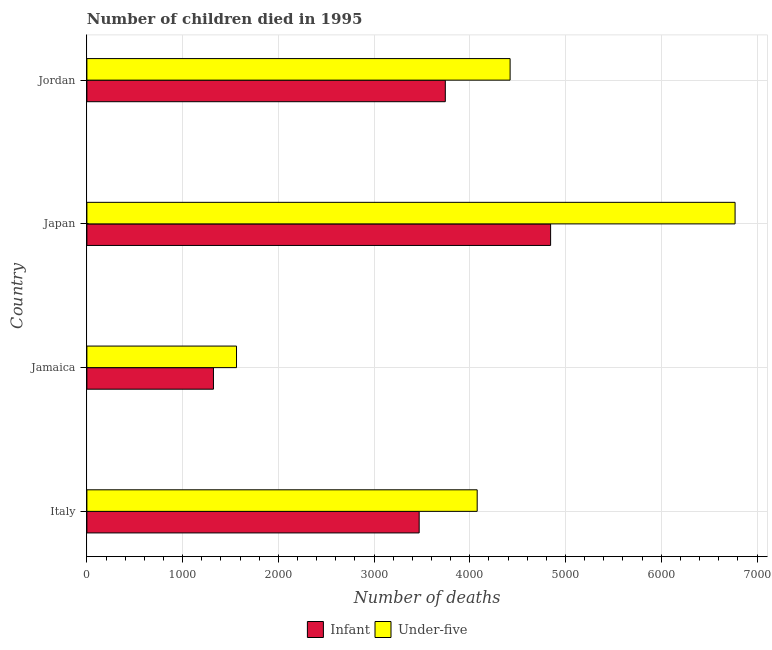How many different coloured bars are there?
Your answer should be very brief. 2. How many groups of bars are there?
Your answer should be compact. 4. Are the number of bars per tick equal to the number of legend labels?
Make the answer very short. Yes. What is the label of the 4th group of bars from the top?
Give a very brief answer. Italy. In how many cases, is the number of bars for a given country not equal to the number of legend labels?
Keep it short and to the point. 0. What is the number of infant deaths in Jordan?
Your answer should be compact. 3744. Across all countries, what is the maximum number of infant deaths?
Offer a very short reply. 4844. Across all countries, what is the minimum number of under-five deaths?
Provide a succinct answer. 1563. In which country was the number of infant deaths maximum?
Make the answer very short. Japan. In which country was the number of under-five deaths minimum?
Provide a succinct answer. Jamaica. What is the total number of under-five deaths in the graph?
Keep it short and to the point. 1.68e+04. What is the difference between the number of infant deaths in Japan and that in Jordan?
Offer a very short reply. 1100. What is the difference between the number of infant deaths in Jordan and the number of under-five deaths in Italy?
Your answer should be compact. -333. What is the average number of infant deaths per country?
Ensure brevity in your answer.  3345.25. What is the difference between the number of infant deaths and number of under-five deaths in Jamaica?
Make the answer very short. -241. What is the ratio of the number of under-five deaths in Jamaica to that in Jordan?
Keep it short and to the point. 0.35. Is the difference between the number of under-five deaths in Jamaica and Jordan greater than the difference between the number of infant deaths in Jamaica and Jordan?
Provide a short and direct response. No. What is the difference between the highest and the second highest number of infant deaths?
Your answer should be very brief. 1100. What is the difference between the highest and the lowest number of infant deaths?
Provide a short and direct response. 3522. What does the 2nd bar from the top in Jamaica represents?
Your answer should be compact. Infant. What does the 1st bar from the bottom in Italy represents?
Keep it short and to the point. Infant. What is the difference between two consecutive major ticks on the X-axis?
Provide a succinct answer. 1000. Are the values on the major ticks of X-axis written in scientific E-notation?
Your response must be concise. No. Does the graph contain grids?
Your answer should be very brief. Yes. Where does the legend appear in the graph?
Give a very brief answer. Bottom center. What is the title of the graph?
Provide a short and direct response. Number of children died in 1995. What is the label or title of the X-axis?
Offer a terse response. Number of deaths. What is the label or title of the Y-axis?
Your response must be concise. Country. What is the Number of deaths in Infant in Italy?
Your answer should be very brief. 3471. What is the Number of deaths of Under-five in Italy?
Your answer should be compact. 4077. What is the Number of deaths of Infant in Jamaica?
Your answer should be very brief. 1322. What is the Number of deaths in Under-five in Jamaica?
Your response must be concise. 1563. What is the Number of deaths in Infant in Japan?
Give a very brief answer. 4844. What is the Number of deaths in Under-five in Japan?
Provide a short and direct response. 6771. What is the Number of deaths of Infant in Jordan?
Your response must be concise. 3744. What is the Number of deaths in Under-five in Jordan?
Your answer should be compact. 4421. Across all countries, what is the maximum Number of deaths in Infant?
Keep it short and to the point. 4844. Across all countries, what is the maximum Number of deaths of Under-five?
Offer a very short reply. 6771. Across all countries, what is the minimum Number of deaths of Infant?
Offer a very short reply. 1322. Across all countries, what is the minimum Number of deaths of Under-five?
Keep it short and to the point. 1563. What is the total Number of deaths in Infant in the graph?
Your answer should be compact. 1.34e+04. What is the total Number of deaths in Under-five in the graph?
Keep it short and to the point. 1.68e+04. What is the difference between the Number of deaths in Infant in Italy and that in Jamaica?
Keep it short and to the point. 2149. What is the difference between the Number of deaths of Under-five in Italy and that in Jamaica?
Offer a very short reply. 2514. What is the difference between the Number of deaths of Infant in Italy and that in Japan?
Your response must be concise. -1373. What is the difference between the Number of deaths of Under-five in Italy and that in Japan?
Keep it short and to the point. -2694. What is the difference between the Number of deaths of Infant in Italy and that in Jordan?
Offer a terse response. -273. What is the difference between the Number of deaths of Under-five in Italy and that in Jordan?
Keep it short and to the point. -344. What is the difference between the Number of deaths of Infant in Jamaica and that in Japan?
Keep it short and to the point. -3522. What is the difference between the Number of deaths in Under-five in Jamaica and that in Japan?
Your answer should be compact. -5208. What is the difference between the Number of deaths of Infant in Jamaica and that in Jordan?
Make the answer very short. -2422. What is the difference between the Number of deaths in Under-five in Jamaica and that in Jordan?
Your answer should be very brief. -2858. What is the difference between the Number of deaths of Infant in Japan and that in Jordan?
Provide a succinct answer. 1100. What is the difference between the Number of deaths in Under-five in Japan and that in Jordan?
Provide a succinct answer. 2350. What is the difference between the Number of deaths of Infant in Italy and the Number of deaths of Under-five in Jamaica?
Your answer should be very brief. 1908. What is the difference between the Number of deaths in Infant in Italy and the Number of deaths in Under-five in Japan?
Offer a very short reply. -3300. What is the difference between the Number of deaths of Infant in Italy and the Number of deaths of Under-five in Jordan?
Give a very brief answer. -950. What is the difference between the Number of deaths in Infant in Jamaica and the Number of deaths in Under-five in Japan?
Provide a short and direct response. -5449. What is the difference between the Number of deaths in Infant in Jamaica and the Number of deaths in Under-five in Jordan?
Offer a terse response. -3099. What is the difference between the Number of deaths of Infant in Japan and the Number of deaths of Under-five in Jordan?
Your response must be concise. 423. What is the average Number of deaths in Infant per country?
Your answer should be compact. 3345.25. What is the average Number of deaths in Under-five per country?
Ensure brevity in your answer.  4208. What is the difference between the Number of deaths of Infant and Number of deaths of Under-five in Italy?
Make the answer very short. -606. What is the difference between the Number of deaths in Infant and Number of deaths in Under-five in Jamaica?
Provide a succinct answer. -241. What is the difference between the Number of deaths of Infant and Number of deaths of Under-five in Japan?
Keep it short and to the point. -1927. What is the difference between the Number of deaths of Infant and Number of deaths of Under-five in Jordan?
Ensure brevity in your answer.  -677. What is the ratio of the Number of deaths of Infant in Italy to that in Jamaica?
Your answer should be very brief. 2.63. What is the ratio of the Number of deaths in Under-five in Italy to that in Jamaica?
Provide a short and direct response. 2.61. What is the ratio of the Number of deaths in Infant in Italy to that in Japan?
Ensure brevity in your answer.  0.72. What is the ratio of the Number of deaths in Under-five in Italy to that in Japan?
Ensure brevity in your answer.  0.6. What is the ratio of the Number of deaths of Infant in Italy to that in Jordan?
Give a very brief answer. 0.93. What is the ratio of the Number of deaths in Under-five in Italy to that in Jordan?
Your answer should be very brief. 0.92. What is the ratio of the Number of deaths of Infant in Jamaica to that in Japan?
Your answer should be very brief. 0.27. What is the ratio of the Number of deaths of Under-five in Jamaica to that in Japan?
Your answer should be compact. 0.23. What is the ratio of the Number of deaths of Infant in Jamaica to that in Jordan?
Offer a very short reply. 0.35. What is the ratio of the Number of deaths in Under-five in Jamaica to that in Jordan?
Provide a short and direct response. 0.35. What is the ratio of the Number of deaths of Infant in Japan to that in Jordan?
Offer a terse response. 1.29. What is the ratio of the Number of deaths in Under-five in Japan to that in Jordan?
Your response must be concise. 1.53. What is the difference between the highest and the second highest Number of deaths in Infant?
Your answer should be compact. 1100. What is the difference between the highest and the second highest Number of deaths of Under-five?
Ensure brevity in your answer.  2350. What is the difference between the highest and the lowest Number of deaths in Infant?
Offer a very short reply. 3522. What is the difference between the highest and the lowest Number of deaths in Under-five?
Give a very brief answer. 5208. 